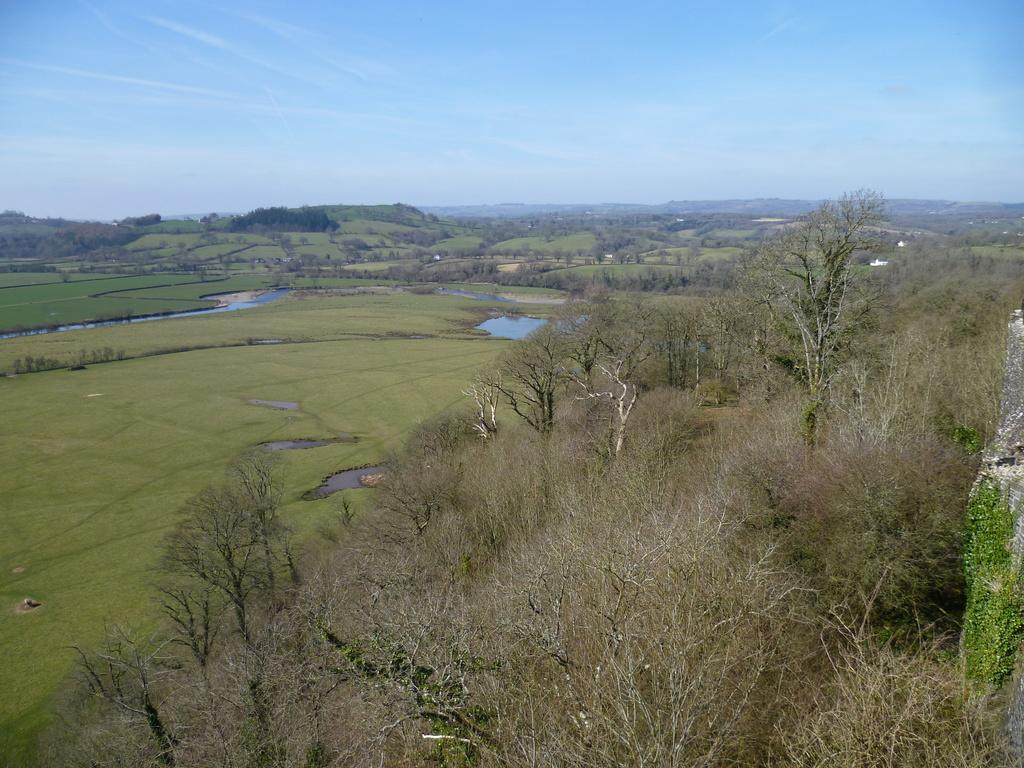What type of vegetation can be seen in the image? There are trees in the image. What type of ground cover is present in the image? There is grass in the image. What bodies of water are visible in the image? There are ponds in the image. What type of geological feature can be seen in the distance? There are mountains in the image. What type of cup is being used to crack open the neck of the mountain in the image? There is no cup or neck of a mountain present in the image. 